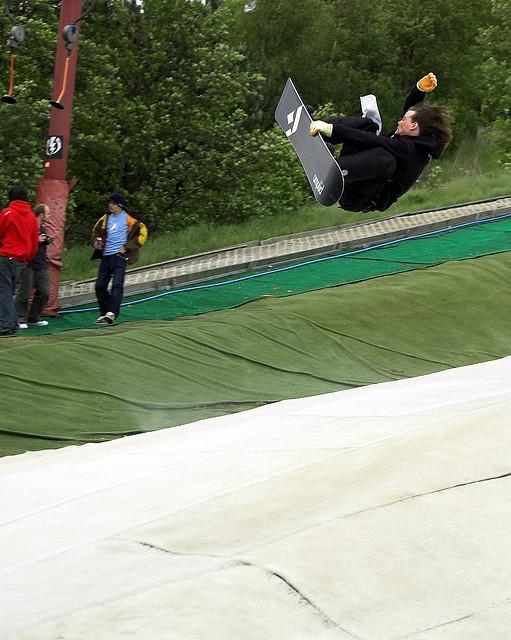What type of board is this? Please explain your reasoning. skate board. The person is on a flat board that doesn't have wheels. 